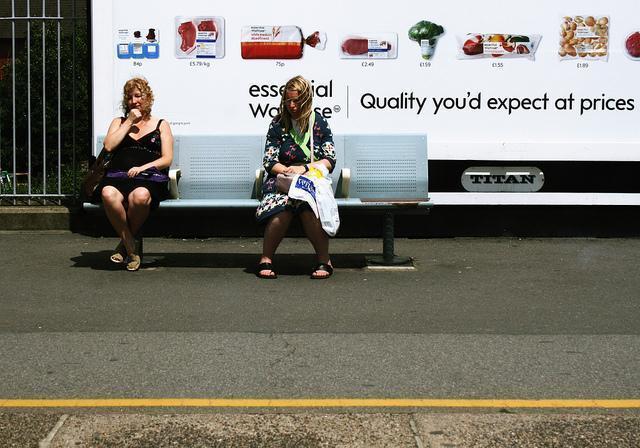What is the large object trying to get you to do?
Pick the right solution, then justify: 'Answer: answer
Rationale: rationale.'
Options: Drive safe, buy goods, watch tv, join army. Answer: buy goods.
Rationale: Advertising can cause people to purchase things. 